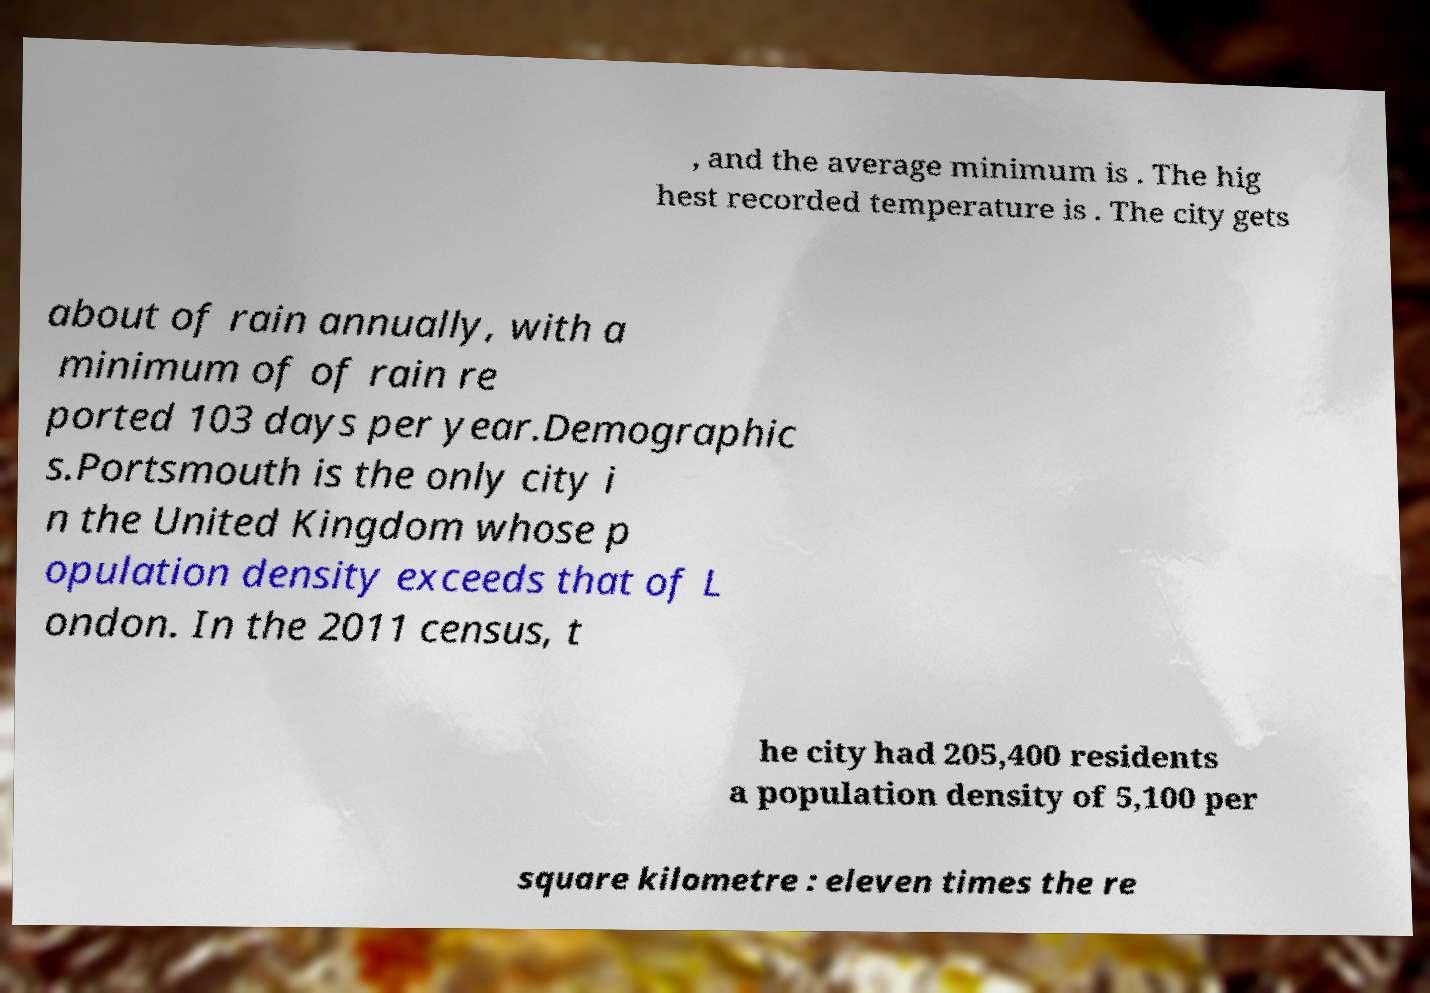Please identify and transcribe the text found in this image. , and the average minimum is . The hig hest recorded temperature is . The city gets about of rain annually, with a minimum of of rain re ported 103 days per year.Demographic s.Portsmouth is the only city i n the United Kingdom whose p opulation density exceeds that of L ondon. In the 2011 census, t he city had 205,400 residents a population density of 5,100 per square kilometre : eleven times the re 